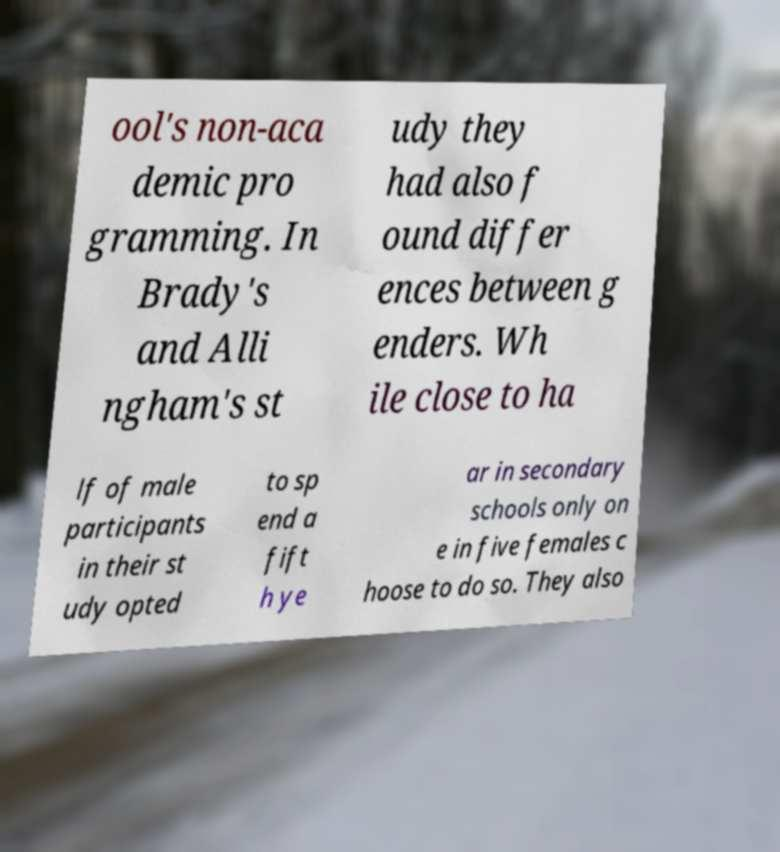For documentation purposes, I need the text within this image transcribed. Could you provide that? ool's non-aca demic pro gramming. In Brady's and Alli ngham's st udy they had also f ound differ ences between g enders. Wh ile close to ha lf of male participants in their st udy opted to sp end a fift h ye ar in secondary schools only on e in five females c hoose to do so. They also 